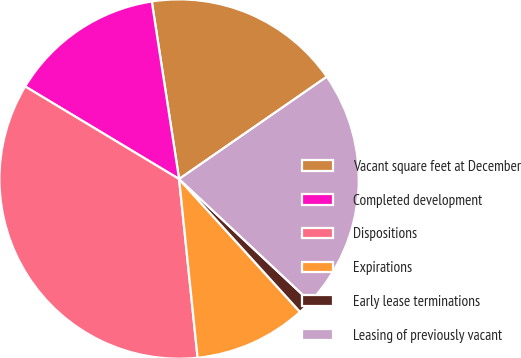Convert chart to OTSL. <chart><loc_0><loc_0><loc_500><loc_500><pie_chart><fcel>Vacant square feet at December<fcel>Completed development<fcel>Dispositions<fcel>Expirations<fcel>Early lease terminations<fcel>Leasing of previously vacant<nl><fcel>17.79%<fcel>13.95%<fcel>35.26%<fcel>10.11%<fcel>1.27%<fcel>21.62%<nl></chart> 